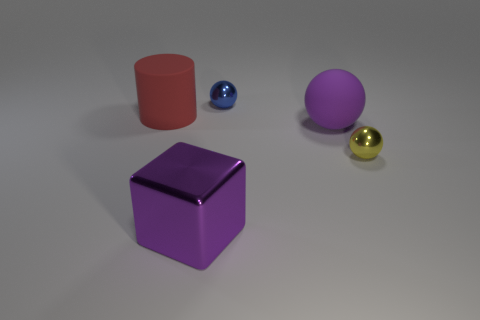Add 5 purple metallic things. How many objects exist? 10 Subtract all tiny blue metallic balls. How many balls are left? 2 Subtract 1 balls. How many balls are left? 2 Add 3 big spheres. How many big spheres exist? 4 Subtract 0 brown blocks. How many objects are left? 5 Subtract all balls. How many objects are left? 2 Subtract all gray cylinders. Subtract all yellow balls. How many cylinders are left? 1 Subtract all large red rubber objects. Subtract all tiny metal spheres. How many objects are left? 2 Add 5 big metal things. How many big metal things are left? 6 